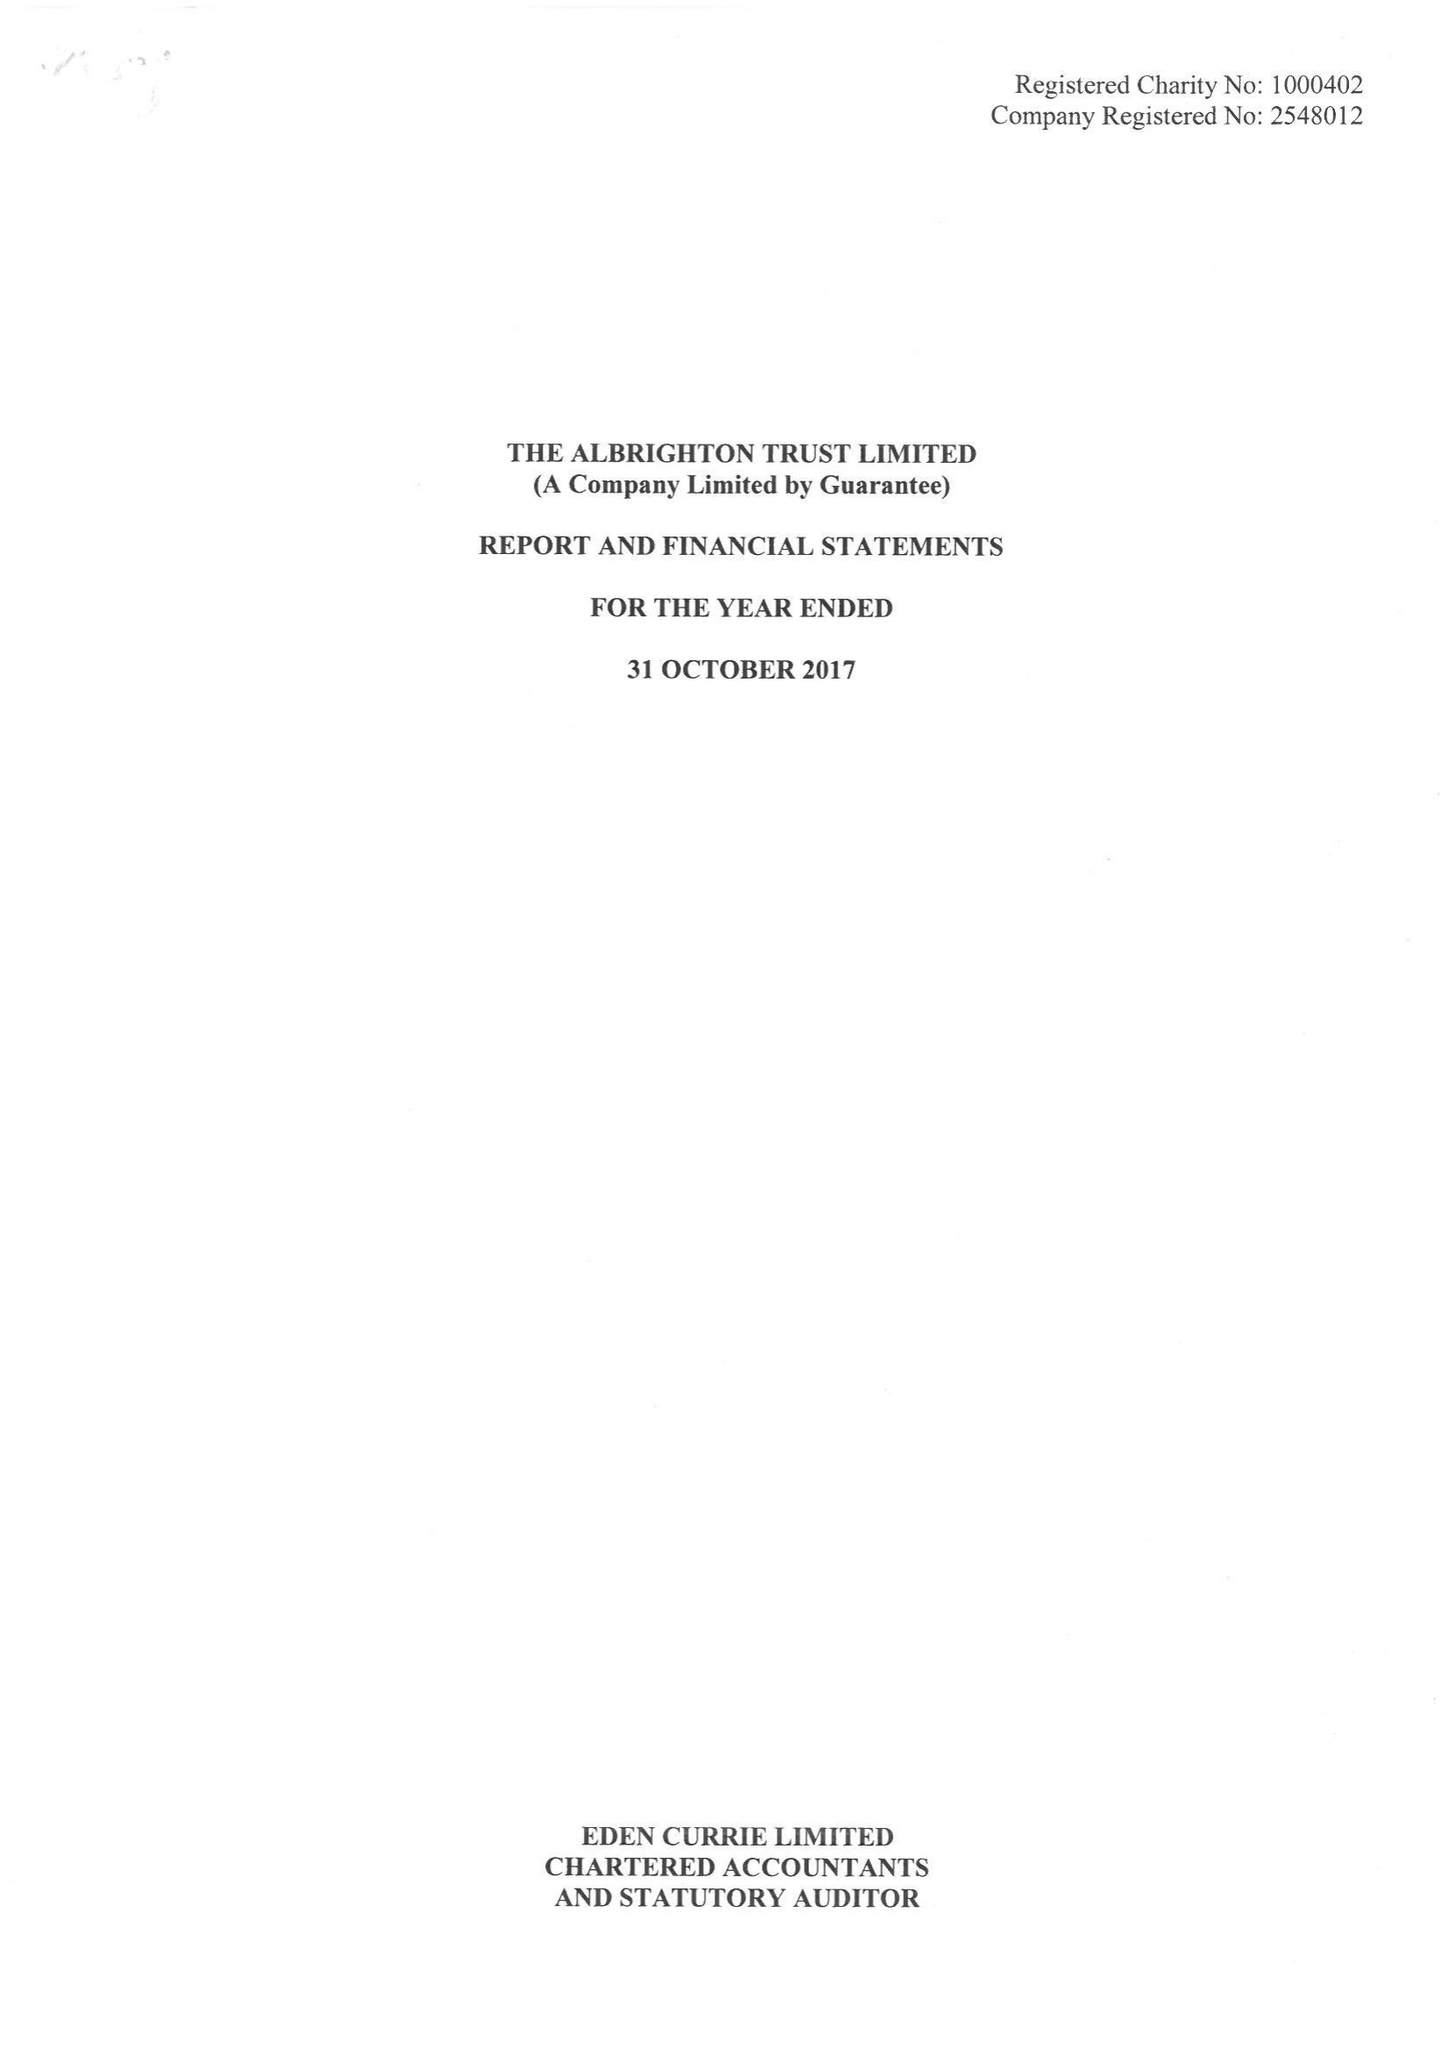What is the value for the address__post_town?
Answer the question using a single word or phrase. WOLVERHAMPTON 